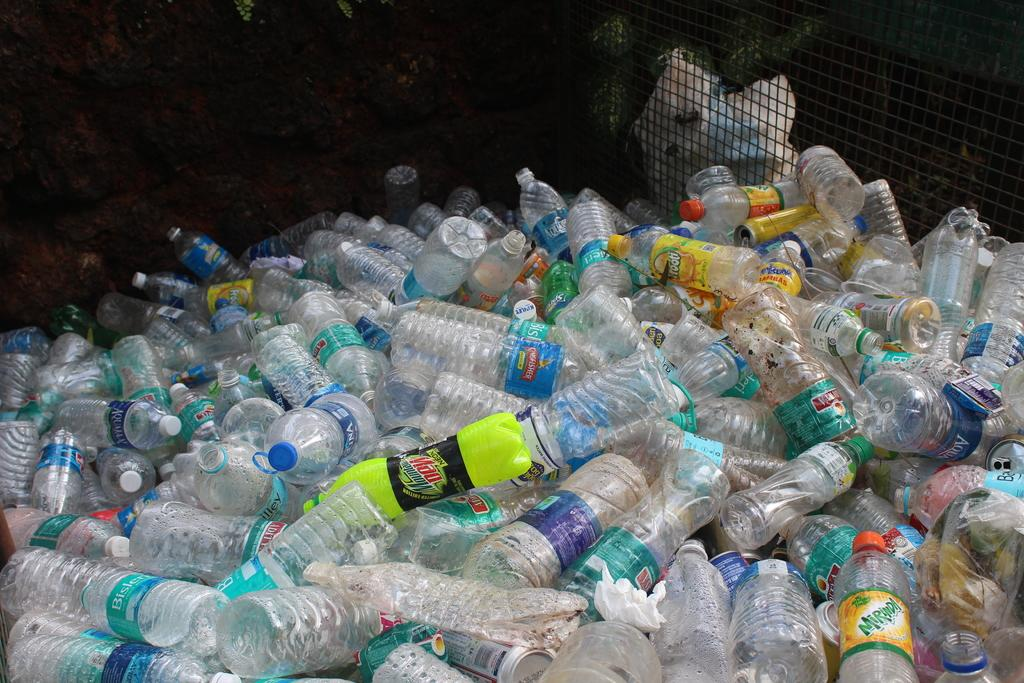Provide a one-sentence caption for the provided image. Plastic bottles are in a pile with some labeled Mt Dew. 